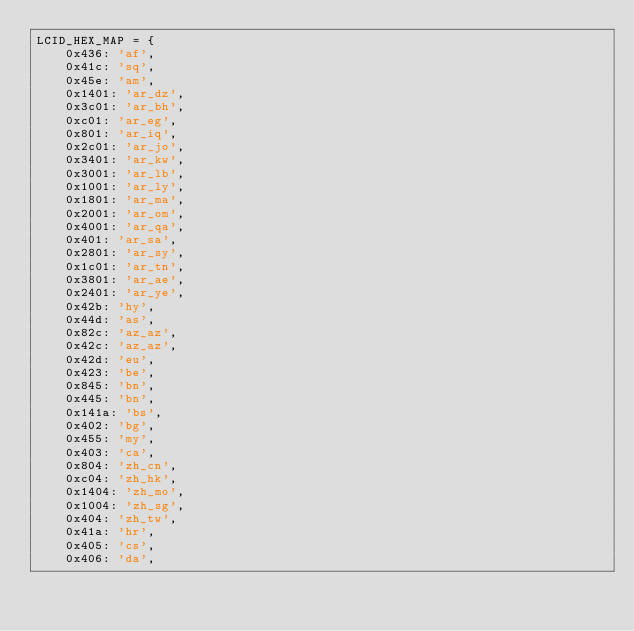<code> <loc_0><loc_0><loc_500><loc_500><_Python_>LCID_HEX_MAP = {
    0x436: 'af',
    0x41c: 'sq',
    0x45e: 'am',
    0x1401: 'ar_dz',
    0x3c01: 'ar_bh',
    0xc01: 'ar_eg',
    0x801: 'ar_iq',
    0x2c01: 'ar_jo',
    0x3401: 'ar_kw',
    0x3001: 'ar_lb',
    0x1001: 'ar_ly',
    0x1801: 'ar_ma',
    0x2001: 'ar_om',
    0x4001: 'ar_qa',
    0x401: 'ar_sa',
    0x2801: 'ar_sy',
    0x1c01: 'ar_tn',
    0x3801: 'ar_ae',
    0x2401: 'ar_ye',
    0x42b: 'hy',
    0x44d: 'as',
    0x82c: 'az_az',
    0x42c: 'az_az',
    0x42d: 'eu',
    0x423: 'be',
    0x845: 'bn',
    0x445: 'bn',
    0x141a: 'bs',
    0x402: 'bg',
    0x455: 'my',
    0x403: 'ca',
    0x804: 'zh_cn',
    0xc04: 'zh_hk',
    0x1404: 'zh_mo',
    0x1004: 'zh_sg',
    0x404: 'zh_tw',
    0x41a: 'hr',
    0x405: 'cs',
    0x406: 'da',</code> 